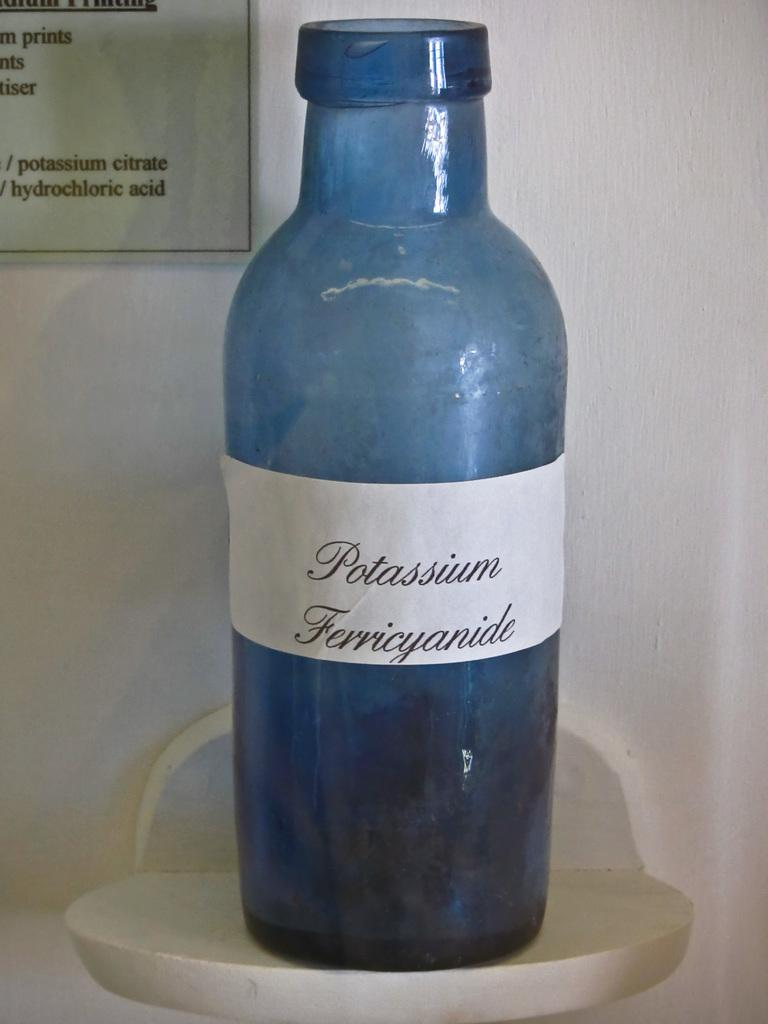<image>
Provide a brief description of the given image. A blue glass bottle of Potassium Ferricyanide on a shelf. 